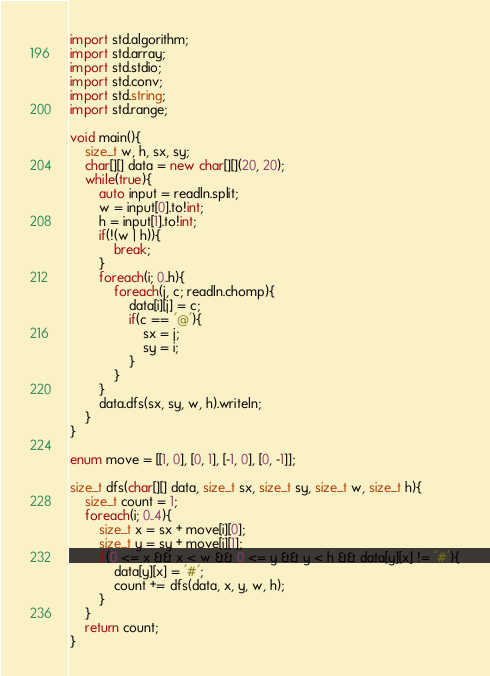Convert code to text. <code><loc_0><loc_0><loc_500><loc_500><_D_>import std.algorithm;
import std.array;
import std.stdio;
import std.conv;
import std.string;
import std.range;

void main(){
    size_t w, h, sx, sy;
    char[][] data = new char[][](20, 20);
    while(true){
        auto input = readln.split;
        w = input[0].to!int;
        h = input[1].to!int;
        if(!(w | h)){
            break;
        }
        foreach(i; 0..h){
            foreach(j, c; readln.chomp){
                data[i][j] = c;
                if(c == '@'){
                    sx = j;
                    sy = i;
                }
            }
        }
        data.dfs(sx, sy, w, h).writeln;
    }
}

enum move = [[1, 0], [0, 1], [-1, 0], [0, -1]];

size_t dfs(char[][] data, size_t sx, size_t sy, size_t w, size_t h){
    size_t count = 1;
    foreach(i; 0..4){
        size_t x = sx + move[i][0];
        size_t y = sy + move[i][1];
        if(0 <= x && x < w && 0 <= y && y < h && data[y][x] != '#'){
            data[y][x] = '#';
            count += dfs(data, x, y, w, h);
        }
    }
    return count;
}</code> 